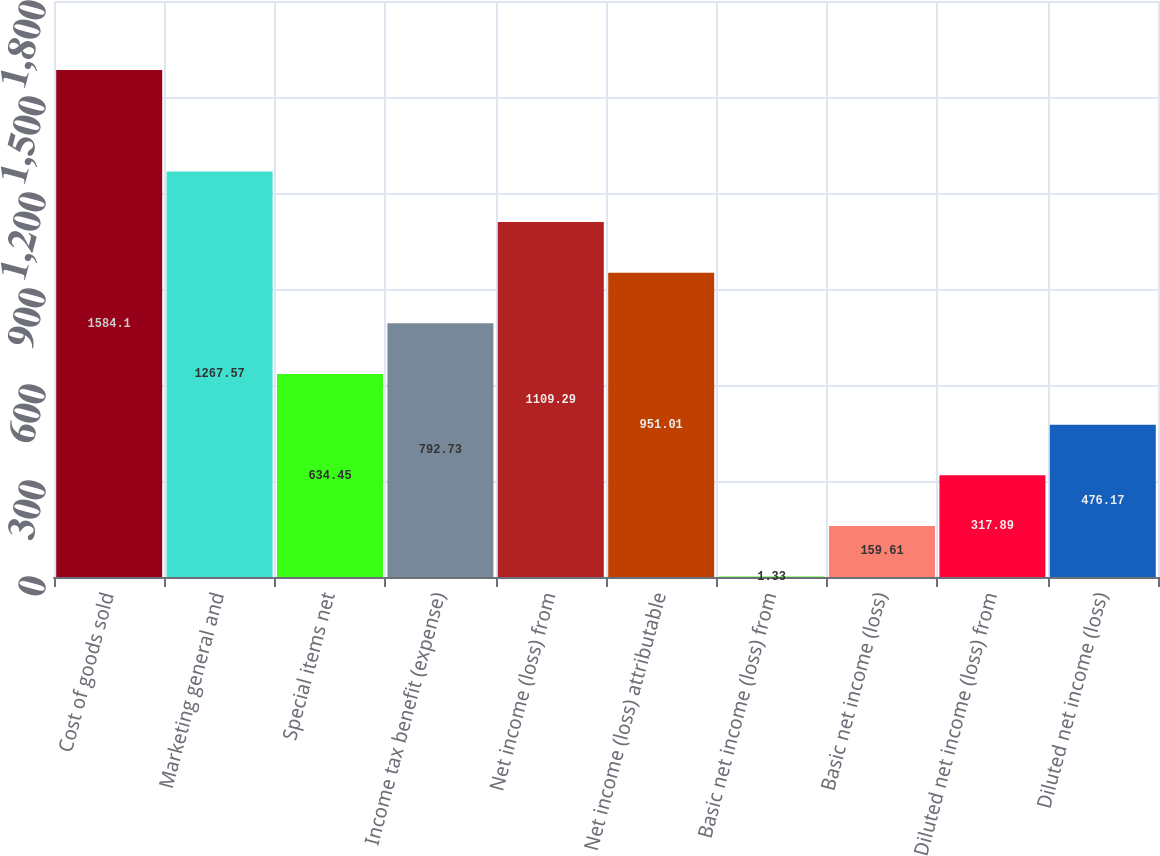<chart> <loc_0><loc_0><loc_500><loc_500><bar_chart><fcel>Cost of goods sold<fcel>Marketing general and<fcel>Special items net<fcel>Income tax benefit (expense)<fcel>Net income (loss) from<fcel>Net income (loss) attributable<fcel>Basic net income (loss) from<fcel>Basic net income (loss)<fcel>Diluted net income (loss) from<fcel>Diluted net income (loss)<nl><fcel>1584.1<fcel>1267.57<fcel>634.45<fcel>792.73<fcel>1109.29<fcel>951.01<fcel>1.33<fcel>159.61<fcel>317.89<fcel>476.17<nl></chart> 